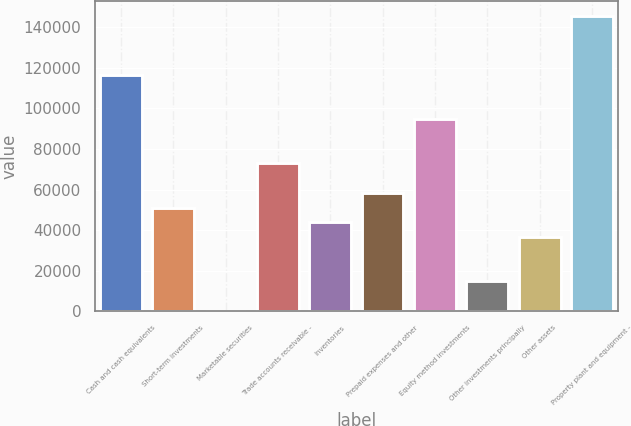<chart> <loc_0><loc_0><loc_500><loc_500><bar_chart><fcel>Cash and cash equivalents<fcel>Short-term investments<fcel>Marketable securities<fcel>Trade accounts receivable -<fcel>Inventories<fcel>Prepaid expenses and other<fcel>Equity method investments<fcel>Other investments principally<fcel>Other assets<fcel>Property plant and equipment -<nl><fcel>116591<fcel>51086.1<fcel>138<fcel>72921<fcel>43807.8<fcel>58364.4<fcel>94755.9<fcel>14694.6<fcel>36529.5<fcel>145704<nl></chart> 